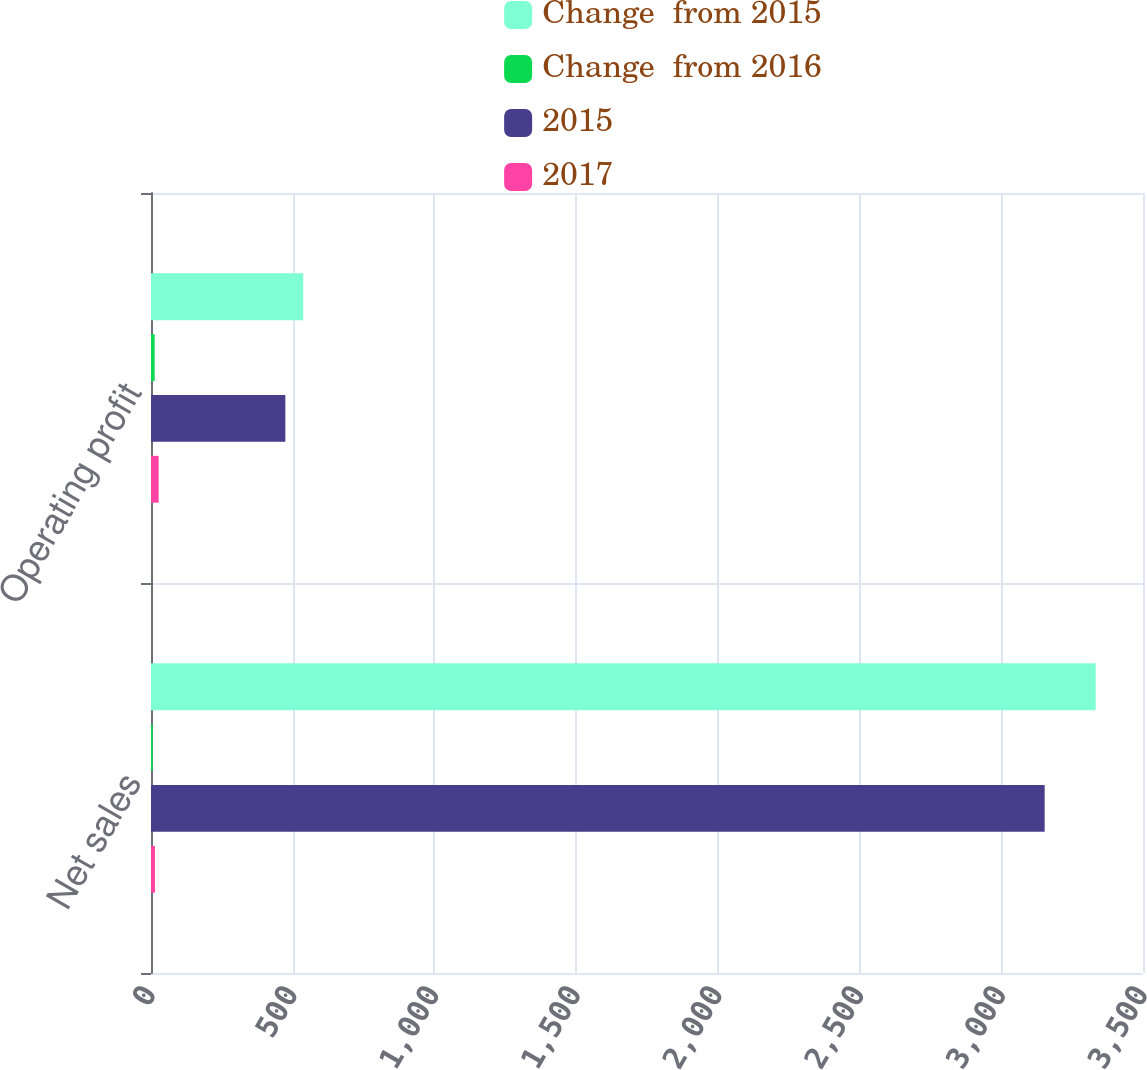Convert chart. <chart><loc_0><loc_0><loc_500><loc_500><stacked_bar_chart><ecel><fcel>Net sales<fcel>Operating profit<nl><fcel>Change  from 2015<fcel>3333<fcel>537<nl><fcel>Change  from 2016<fcel>6<fcel>13<nl><fcel>2015<fcel>3153<fcel>474<nl><fcel>2017<fcel>14<fcel>27<nl></chart> 